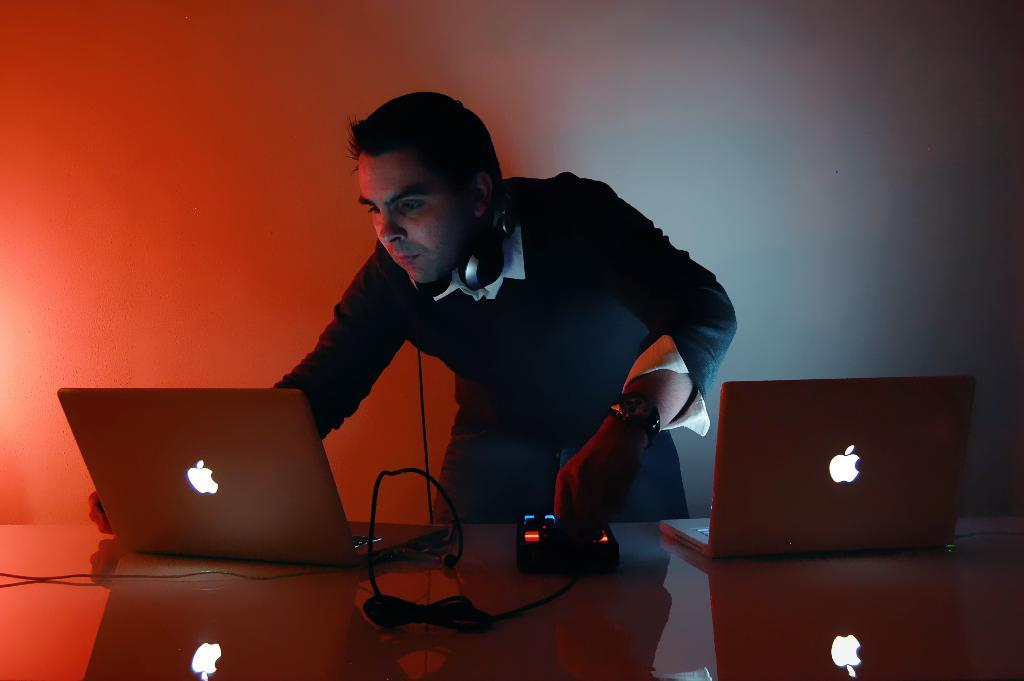Who is the main subject in the image? There is a man in the image. What is the man doing in the image? The man is operating a laptop. Are there any other laptops visible in the image? Yes, there is another laptop visible in the image. What type of jelly is being used to type on the laptop in the image? There is no jelly present in the image, and it is not being used to type on the laptop. 